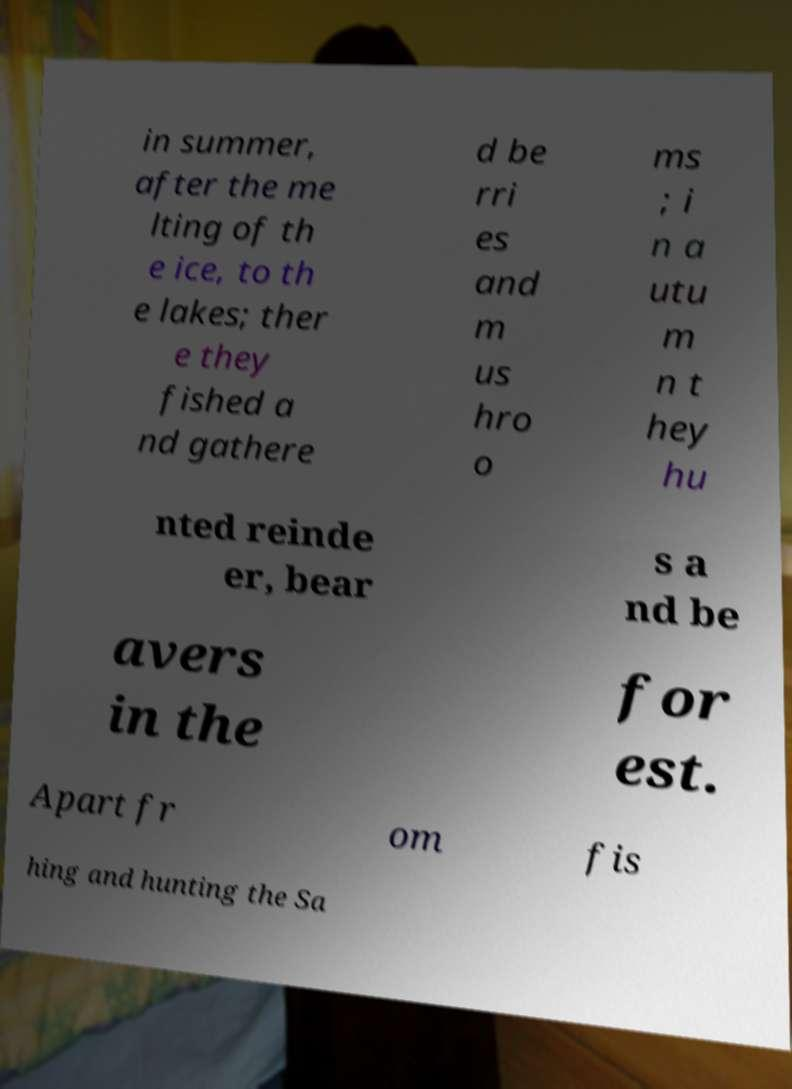Could you extract and type out the text from this image? in summer, after the me lting of th e ice, to th e lakes; ther e they fished a nd gathere d be rri es and m us hro o ms ; i n a utu m n t hey hu nted reinde er, bear s a nd be avers in the for est. Apart fr om fis hing and hunting the Sa 